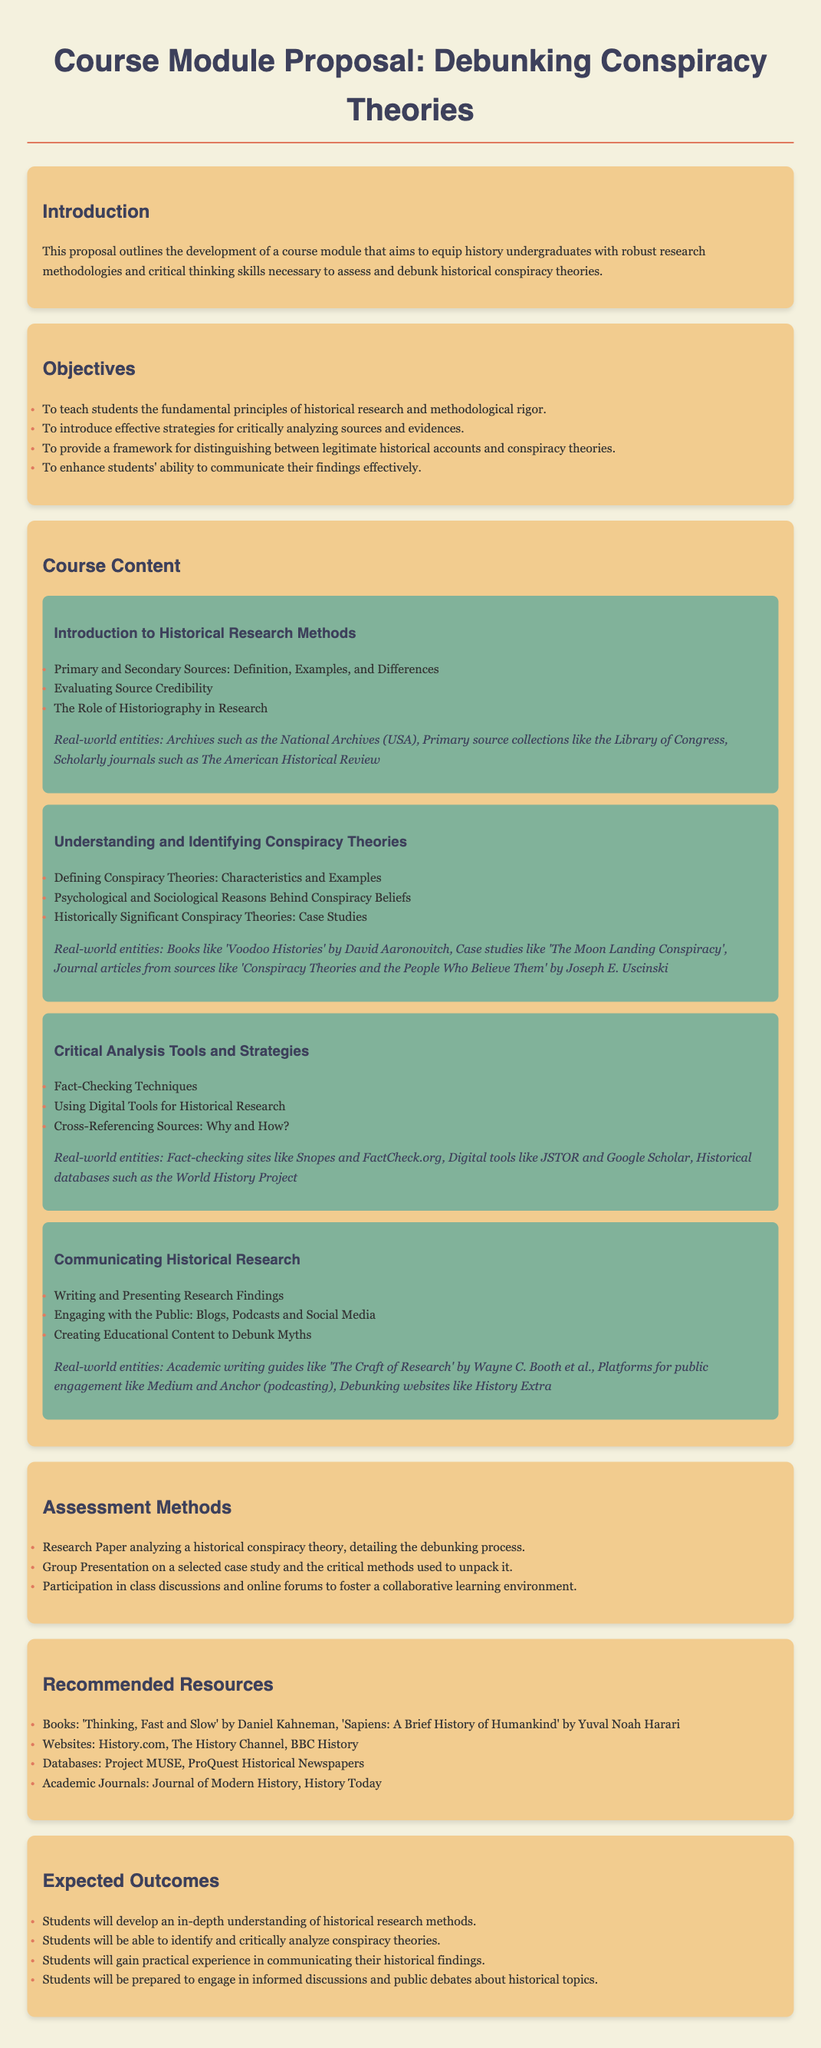What is the main goal of the course module? The proposal outlines the development of a course module that aims to equip history undergraduates with robust research methodologies and critical thinking skills necessary to assess and debunk historical conspiracy theories.
Answer: To equip history undergraduates What is one of the assessment methods mentioned? The document lists various methods to assess students' understanding and skills.
Answer: Research Paper Name a real-world entity mentioned in the "Introduction to Historical Research Methods" module. The document references several real-world entities that provide resources for historical research.
Answer: National Archives How many modules are included in the course content? The number of distinct sections labeled as modules will provide the answer.
Answer: Four What is one psychological reason discussed behind conspiracy beliefs? This question seeks to identify a specific topic discussed within the content of the module on conspiracy theories.
Answer: Psychological reasons What type of content will students create to debunk myths? This question asks about a specific activity students will engage in during the course.
Answer: Educational Content How many objectives are there in the proposal? Counting the objectives listed in the section provides the answer.
Answer: Four Which book is recommended in the "Recommended Resources" section? The proposal lists various resources, including examples of recommended books for students.
Answer: Thinking, Fast and Slow What skill will students gain experience in as part of the expected outcomes? This question refers to a specific skill outlined under the expected outcomes of the course.
Answer: Communicating historical findings 